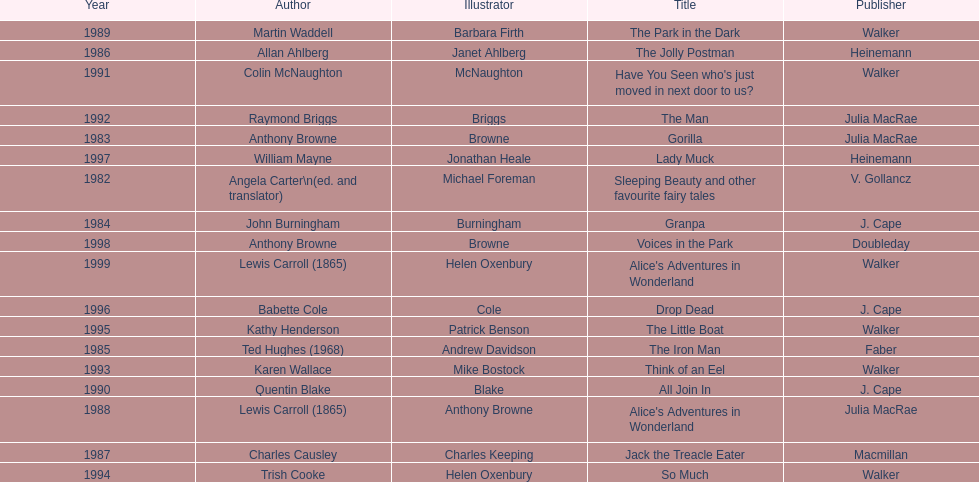Could you parse the entire table? {'header': ['Year', 'Author', 'Illustrator', 'Title', 'Publisher'], 'rows': [['1989', 'Martin Waddell', 'Barbara Firth', 'The Park in the Dark', 'Walker'], ['1986', 'Allan Ahlberg', 'Janet Ahlberg', 'The Jolly Postman', 'Heinemann'], ['1991', 'Colin McNaughton', 'McNaughton', "Have You Seen who's just moved in next door to us?", 'Walker'], ['1992', 'Raymond Briggs', 'Briggs', 'The Man', 'Julia MacRae'], ['1983', 'Anthony Browne', 'Browne', 'Gorilla', 'Julia MacRae'], ['1997', 'William Mayne', 'Jonathan Heale', 'Lady Muck', 'Heinemann'], ['1982', 'Angela Carter\\n(ed. and translator)', 'Michael Foreman', 'Sleeping Beauty and other favourite fairy tales', 'V. Gollancz'], ['1984', 'John Burningham', 'Burningham', 'Granpa', 'J. Cape'], ['1998', 'Anthony Browne', 'Browne', 'Voices in the Park', 'Doubleday'], ['1999', 'Lewis Carroll (1865)', 'Helen Oxenbury', "Alice's Adventures in Wonderland", 'Walker'], ['1996', 'Babette Cole', 'Cole', 'Drop Dead', 'J. Cape'], ['1995', 'Kathy Henderson', 'Patrick Benson', 'The Little Boat', 'Walker'], ['1985', 'Ted Hughes (1968)', 'Andrew Davidson', 'The Iron Man', 'Faber'], ['1993', 'Karen Wallace', 'Mike Bostock', 'Think of an Eel', 'Walker'], ['1990', 'Quentin Blake', 'Blake', 'All Join In', 'J. Cape'], ['1988', 'Lewis Carroll (1865)', 'Anthony Browne', "Alice's Adventures in Wonderland", 'Julia MacRae'], ['1987', 'Charles Causley', 'Charles Keeping', 'Jack the Treacle Eater', 'Macmillan'], ['1994', 'Trish Cooke', 'Helen Oxenbury', 'So Much', 'Walker']]} Which author wrote the first award winner? Angela Carter. 